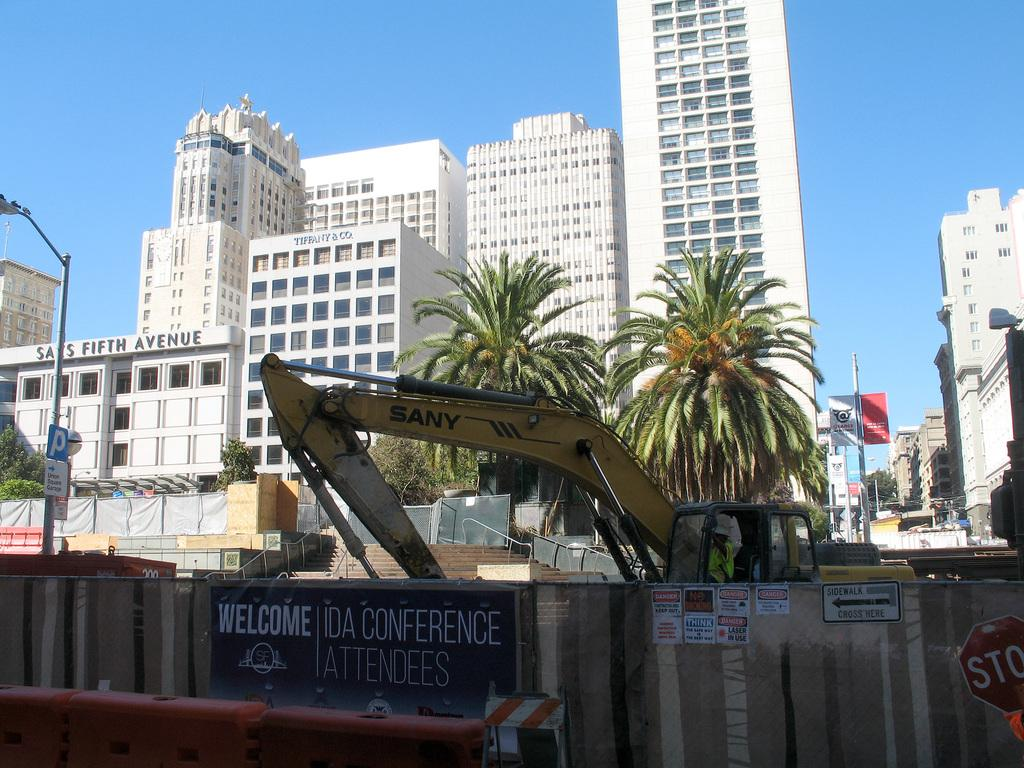What type of vertical structures can be seen in the image? There are light poles in the image. What type of decorative or informative items are present in the image? Banners, boards, hoardings, posters, and signboards are present in the image. What type of structures are visible in the image? Buildings are in the image. What type of natural elements can be seen in the image? Trees are present in the image. What type of architectural feature can be seen in the image? Steps are visible in the image. What type of construction equipment is in the image? A crane is in the image. Are there any people visible in the image? Yes, there is a person in the image. What color is the sky in the image? The sky is blue in the image. What type of pancake is being flipped by the person in the image? There is no pancake present in the image, and the person is not performing any action related to flipping a pancake. How many pages are visible in the image? There are no pages present in the image. 